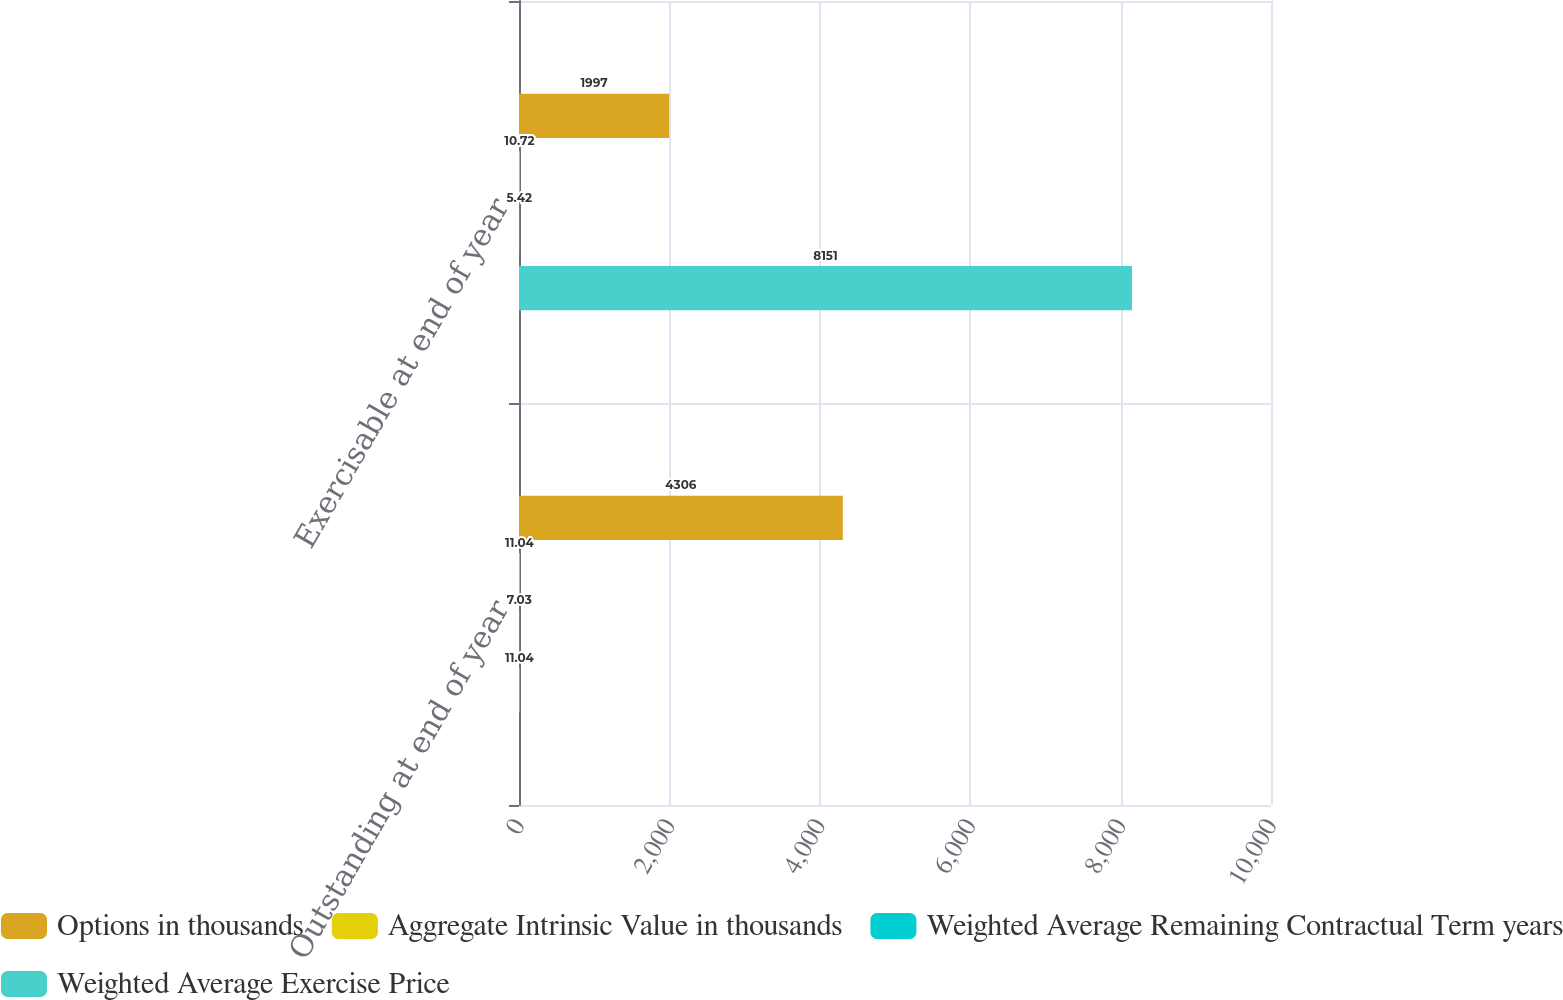<chart> <loc_0><loc_0><loc_500><loc_500><stacked_bar_chart><ecel><fcel>Outstanding at end of year<fcel>Exercisable at end of year<nl><fcel>Options in thousands<fcel>4306<fcel>1997<nl><fcel>Aggregate Intrinsic Value in thousands<fcel>11.04<fcel>10.72<nl><fcel>Weighted Average Remaining Contractual Term years<fcel>7.03<fcel>5.42<nl><fcel>Weighted Average Exercise Price<fcel>11.04<fcel>8151<nl></chart> 